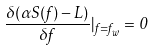<formula> <loc_0><loc_0><loc_500><loc_500>\frac { \delta ( \alpha S ( f ) - L ) } { \delta f } | _ { f = f _ { w } } = 0</formula> 